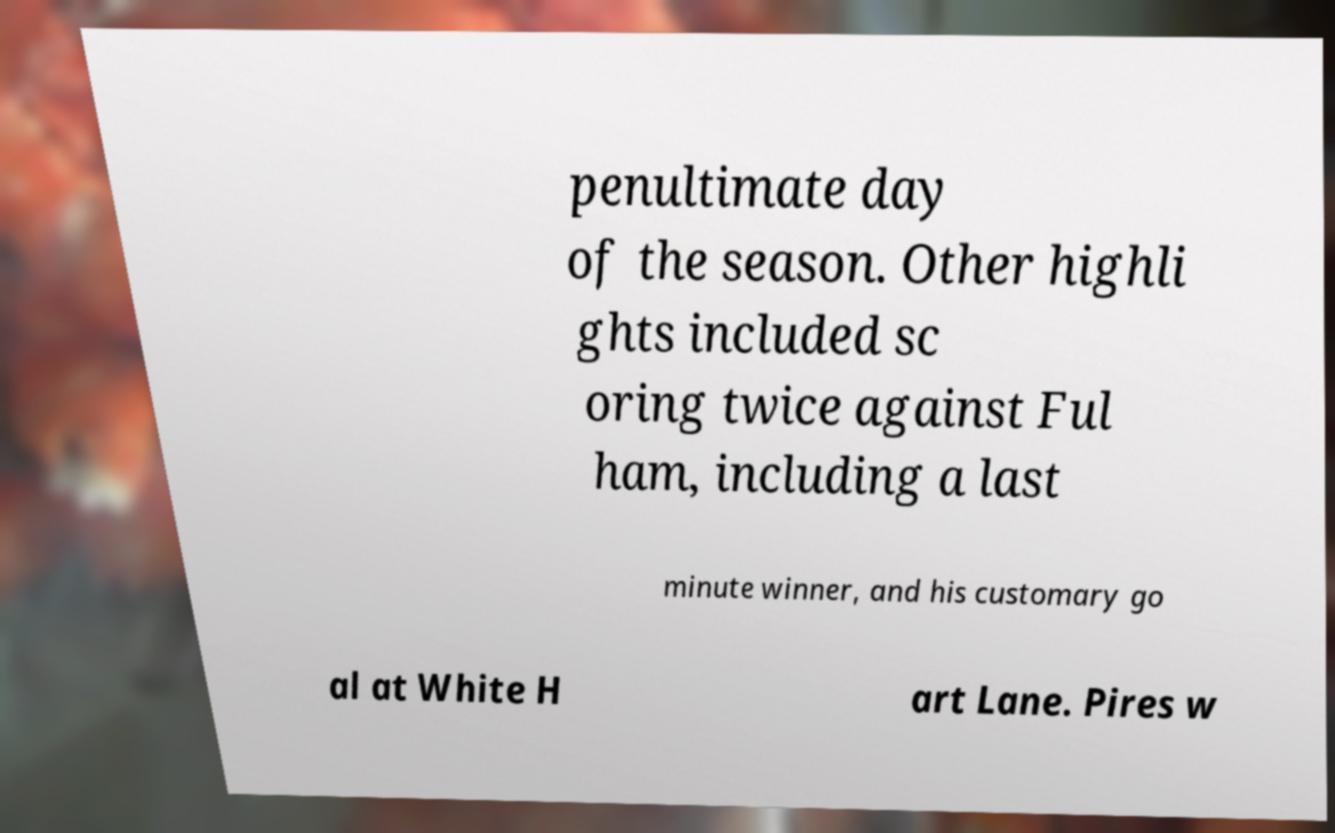There's text embedded in this image that I need extracted. Can you transcribe it verbatim? penultimate day of the season. Other highli ghts included sc oring twice against Ful ham, including a last minute winner, and his customary go al at White H art Lane. Pires w 